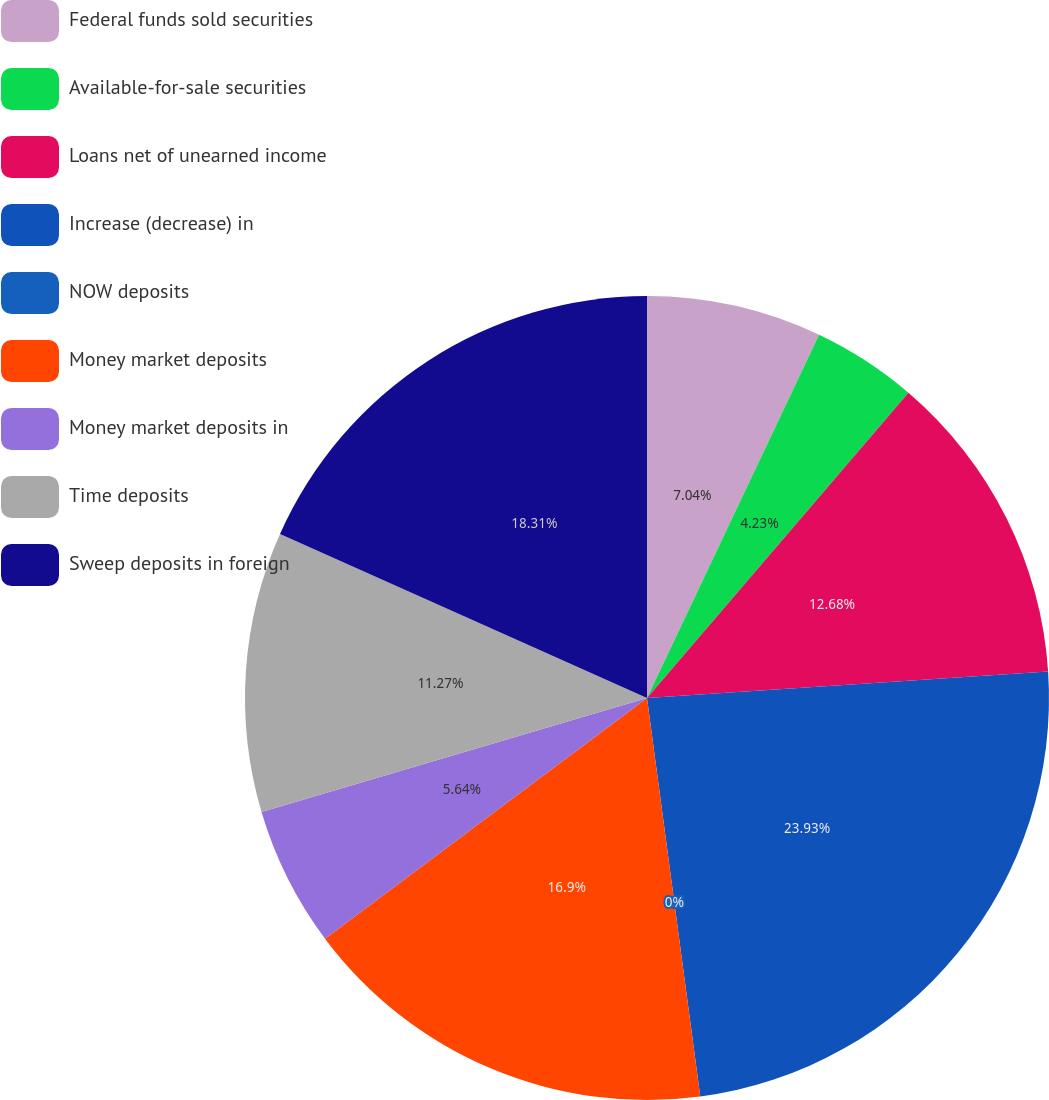Convert chart to OTSL. <chart><loc_0><loc_0><loc_500><loc_500><pie_chart><fcel>Federal funds sold securities<fcel>Available-for-sale securities<fcel>Loans net of unearned income<fcel>Increase (decrease) in<fcel>NOW deposits<fcel>Money market deposits<fcel>Money market deposits in<fcel>Time deposits<fcel>Sweep deposits in foreign<nl><fcel>7.04%<fcel>4.23%<fcel>12.68%<fcel>23.94%<fcel>0.0%<fcel>16.9%<fcel>5.64%<fcel>11.27%<fcel>18.31%<nl></chart> 